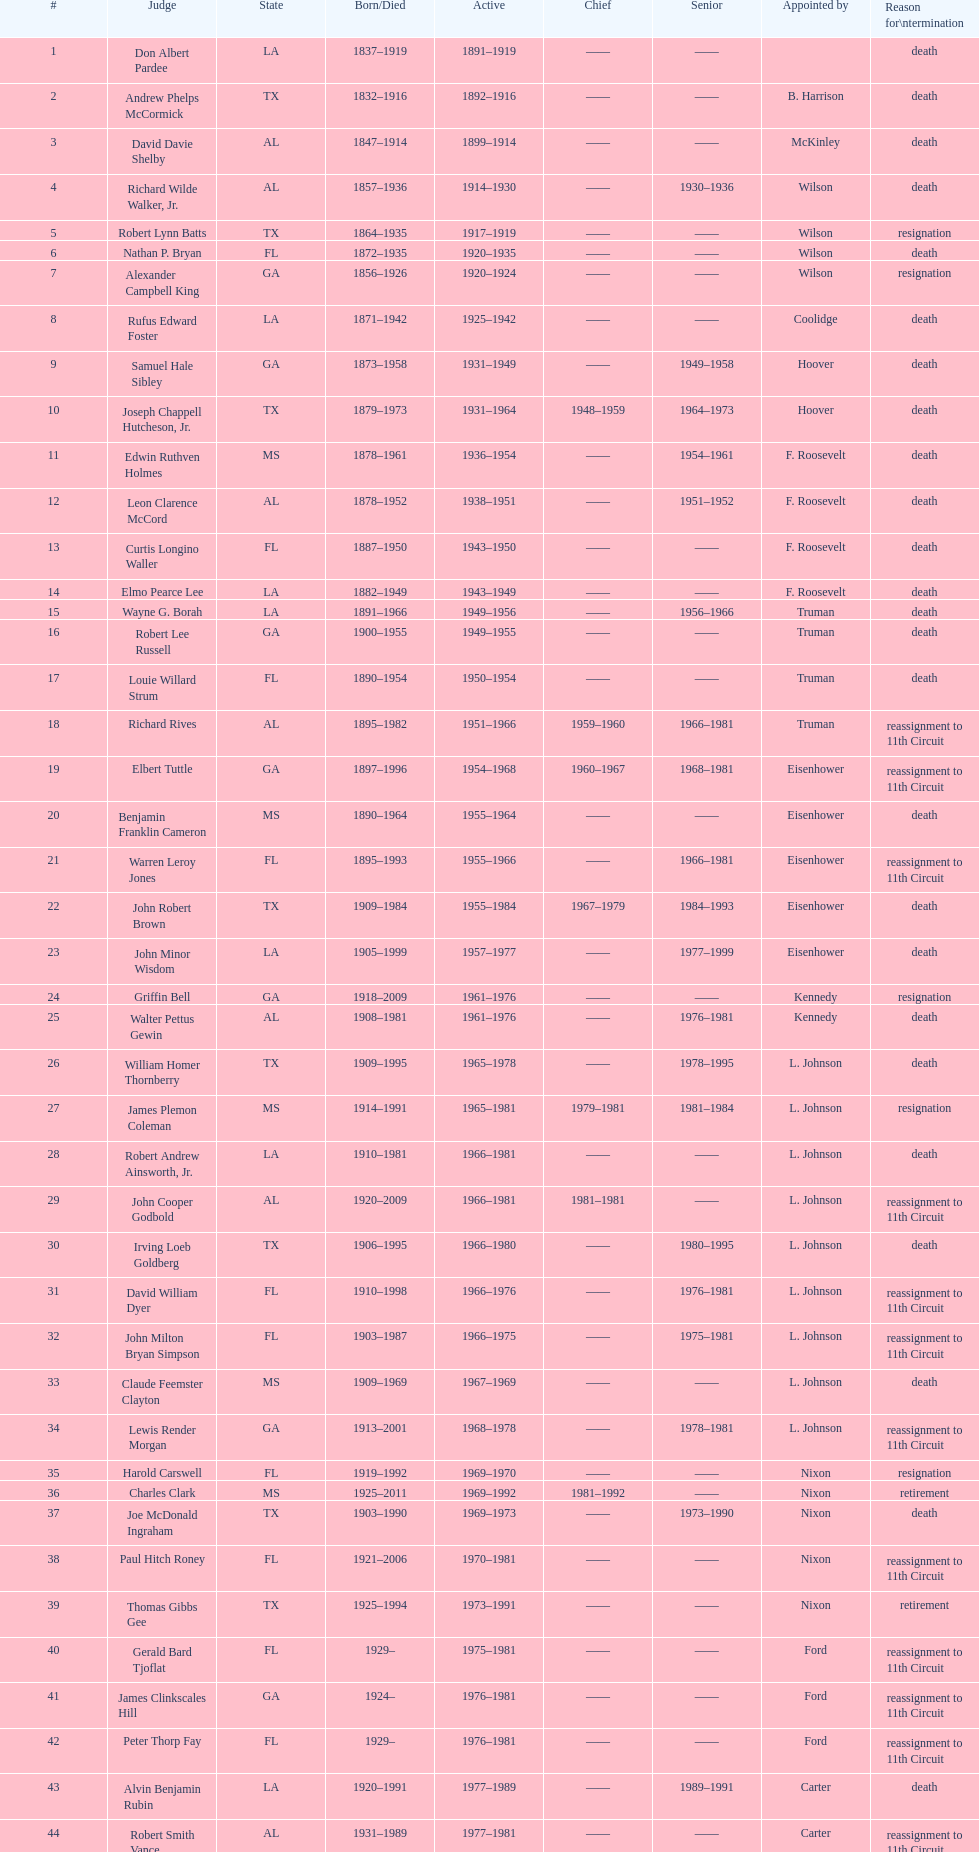Help me parse the entirety of this table. {'header': ['#', 'Judge', 'State', 'Born/Died', 'Active', 'Chief', 'Senior', 'Appointed by', 'Reason for\\ntermination'], 'rows': [['1', 'Don Albert Pardee', 'LA', '1837–1919', '1891–1919', '——', '——', '', 'death'], ['2', 'Andrew Phelps McCormick', 'TX', '1832–1916', '1892–1916', '——', '——', 'B. Harrison', 'death'], ['3', 'David Davie Shelby', 'AL', '1847–1914', '1899–1914', '——', '——', 'McKinley', 'death'], ['4', 'Richard Wilde Walker, Jr.', 'AL', '1857–1936', '1914–1930', '——', '1930–1936', 'Wilson', 'death'], ['5', 'Robert Lynn Batts', 'TX', '1864–1935', '1917–1919', '——', '——', 'Wilson', 'resignation'], ['6', 'Nathan P. Bryan', 'FL', '1872–1935', '1920–1935', '——', '——', 'Wilson', 'death'], ['7', 'Alexander Campbell King', 'GA', '1856–1926', '1920–1924', '——', '——', 'Wilson', 'resignation'], ['8', 'Rufus Edward Foster', 'LA', '1871–1942', '1925–1942', '——', '——', 'Coolidge', 'death'], ['9', 'Samuel Hale Sibley', 'GA', '1873–1958', '1931–1949', '——', '1949–1958', 'Hoover', 'death'], ['10', 'Joseph Chappell Hutcheson, Jr.', 'TX', '1879–1973', '1931–1964', '1948–1959', '1964–1973', 'Hoover', 'death'], ['11', 'Edwin Ruthven Holmes', 'MS', '1878–1961', '1936–1954', '——', '1954–1961', 'F. Roosevelt', 'death'], ['12', 'Leon Clarence McCord', 'AL', '1878–1952', '1938–1951', '——', '1951–1952', 'F. Roosevelt', 'death'], ['13', 'Curtis Longino Waller', 'FL', '1887–1950', '1943–1950', '——', '——', 'F. Roosevelt', 'death'], ['14', 'Elmo Pearce Lee', 'LA', '1882–1949', '1943–1949', '——', '——', 'F. Roosevelt', 'death'], ['15', 'Wayne G. Borah', 'LA', '1891–1966', '1949–1956', '——', '1956–1966', 'Truman', 'death'], ['16', 'Robert Lee Russell', 'GA', '1900–1955', '1949–1955', '——', '——', 'Truman', 'death'], ['17', 'Louie Willard Strum', 'FL', '1890–1954', '1950–1954', '——', '——', 'Truman', 'death'], ['18', 'Richard Rives', 'AL', '1895–1982', '1951–1966', '1959–1960', '1966–1981', 'Truman', 'reassignment to 11th Circuit'], ['19', 'Elbert Tuttle', 'GA', '1897–1996', '1954–1968', '1960–1967', '1968–1981', 'Eisenhower', 'reassignment to 11th Circuit'], ['20', 'Benjamin Franklin Cameron', 'MS', '1890–1964', '1955–1964', '——', '——', 'Eisenhower', 'death'], ['21', 'Warren Leroy Jones', 'FL', '1895–1993', '1955–1966', '——', '1966–1981', 'Eisenhower', 'reassignment to 11th Circuit'], ['22', 'John Robert Brown', 'TX', '1909–1984', '1955–1984', '1967–1979', '1984–1993', 'Eisenhower', 'death'], ['23', 'John Minor Wisdom', 'LA', '1905–1999', '1957–1977', '——', '1977–1999', 'Eisenhower', 'death'], ['24', 'Griffin Bell', 'GA', '1918–2009', '1961–1976', '——', '——', 'Kennedy', 'resignation'], ['25', 'Walter Pettus Gewin', 'AL', '1908–1981', '1961–1976', '——', '1976–1981', 'Kennedy', 'death'], ['26', 'William Homer Thornberry', 'TX', '1909–1995', '1965–1978', '——', '1978–1995', 'L. Johnson', 'death'], ['27', 'James Plemon Coleman', 'MS', '1914–1991', '1965–1981', '1979–1981', '1981–1984', 'L. Johnson', 'resignation'], ['28', 'Robert Andrew Ainsworth, Jr.', 'LA', '1910–1981', '1966–1981', '——', '——', 'L. Johnson', 'death'], ['29', 'John Cooper Godbold', 'AL', '1920–2009', '1966–1981', '1981–1981', '——', 'L. Johnson', 'reassignment to 11th Circuit'], ['30', 'Irving Loeb Goldberg', 'TX', '1906–1995', '1966–1980', '——', '1980–1995', 'L. Johnson', 'death'], ['31', 'David William Dyer', 'FL', '1910–1998', '1966–1976', '——', '1976–1981', 'L. Johnson', 'reassignment to 11th Circuit'], ['32', 'John Milton Bryan Simpson', 'FL', '1903–1987', '1966–1975', '——', '1975–1981', 'L. Johnson', 'reassignment to 11th Circuit'], ['33', 'Claude Feemster Clayton', 'MS', '1909–1969', '1967–1969', '——', '——', 'L. Johnson', 'death'], ['34', 'Lewis Render Morgan', 'GA', '1913–2001', '1968–1978', '——', '1978–1981', 'L. Johnson', 'reassignment to 11th Circuit'], ['35', 'Harold Carswell', 'FL', '1919–1992', '1969–1970', '——', '——', 'Nixon', 'resignation'], ['36', 'Charles Clark', 'MS', '1925–2011', '1969–1992', '1981–1992', '——', 'Nixon', 'retirement'], ['37', 'Joe McDonald Ingraham', 'TX', '1903–1990', '1969–1973', '——', '1973–1990', 'Nixon', 'death'], ['38', 'Paul Hitch Roney', 'FL', '1921–2006', '1970–1981', '——', '——', 'Nixon', 'reassignment to 11th Circuit'], ['39', 'Thomas Gibbs Gee', 'TX', '1925–1994', '1973–1991', '——', '——', 'Nixon', 'retirement'], ['40', 'Gerald Bard Tjoflat', 'FL', '1929–', '1975–1981', '——', '——', 'Ford', 'reassignment to 11th Circuit'], ['41', 'James Clinkscales Hill', 'GA', '1924–', '1976–1981', '——', '——', 'Ford', 'reassignment to 11th Circuit'], ['42', 'Peter Thorp Fay', 'FL', '1929–', '1976–1981', '——', '——', 'Ford', 'reassignment to 11th Circuit'], ['43', 'Alvin Benjamin Rubin', 'LA', '1920–1991', '1977–1989', '——', '1989–1991', 'Carter', 'death'], ['44', 'Robert Smith Vance', 'AL', '1931–1989', '1977–1981', '——', '——', 'Carter', 'reassignment to 11th Circuit'], ['45', 'Phyllis A. Kravitch', 'GA', '1920–', '1979–1981', '——', '——', 'Carter', 'reassignment to 11th Circuit'], ['46', 'Frank Minis Johnson', 'AL', '1918–1999', '1979–1981', '——', '——', 'Carter', 'reassignment to 11th Circuit'], ['47', 'R. Lanier Anderson III', 'GA', '1936–', '1979–1981', '——', '——', 'Carter', 'reassignment to 11th Circuit'], ['48', 'Reynaldo Guerra Garza', 'TX', '1915–2004', '1979–1982', '——', '1982–2004', 'Carter', 'death'], ['49', 'Joseph Woodrow Hatchett', 'FL', '1932–', '1979–1981', '——', '——', 'Carter', 'reassignment to 11th Circuit'], ['50', 'Albert John Henderson', 'GA', '1920–1999', '1979–1981', '——', '——', 'Carter', 'reassignment to 11th Circuit'], ['52', 'Henry Anthony Politz', 'LA', '1932–2002', '1979–1999', '1992–1999', '1999–2002', 'Carter', 'death'], ['54', 'Samuel D. Johnson, Jr.', 'TX', '1920–2002', '1979–1991', '——', '1991–2002', 'Carter', 'death'], ['55', 'Albert Tate, Jr.', 'LA', '1920–1986', '1979–1986', '——', '——', 'Carter', 'death'], ['56', 'Thomas Alonzo Clark', 'GA', '1920–2005', '1979–1981', '——', '——', 'Carter', 'reassignment to 11th Circuit'], ['57', 'Jerre Stockton Williams', 'TX', '1916–1993', '1980–1990', '——', '1990–1993', 'Carter', 'death'], ['58', 'William Lockhart Garwood', 'TX', '1931–2011', '1981–1997', '——', '1997–2011', 'Reagan', 'death'], ['62', 'Robert Madden Hill', 'TX', '1928–1987', '1984–1987', '——', '——', 'Reagan', 'death'], ['65', 'John Malcolm Duhé, Jr.', 'LA', '1933-', '1988–1999', '——', '1999–2011', 'Reagan', 'retirement'], ['72', 'Robert Manley Parker', 'TX', '1937–', '1994–2002', '——', '——', 'Clinton', 'retirement'], ['76', 'Charles W. Pickering', 'MS', '1937–', '2004–2004', '——', '——', 'G.W. Bush', 'retirement']]} Name a state listed at least 4 times. TX. 